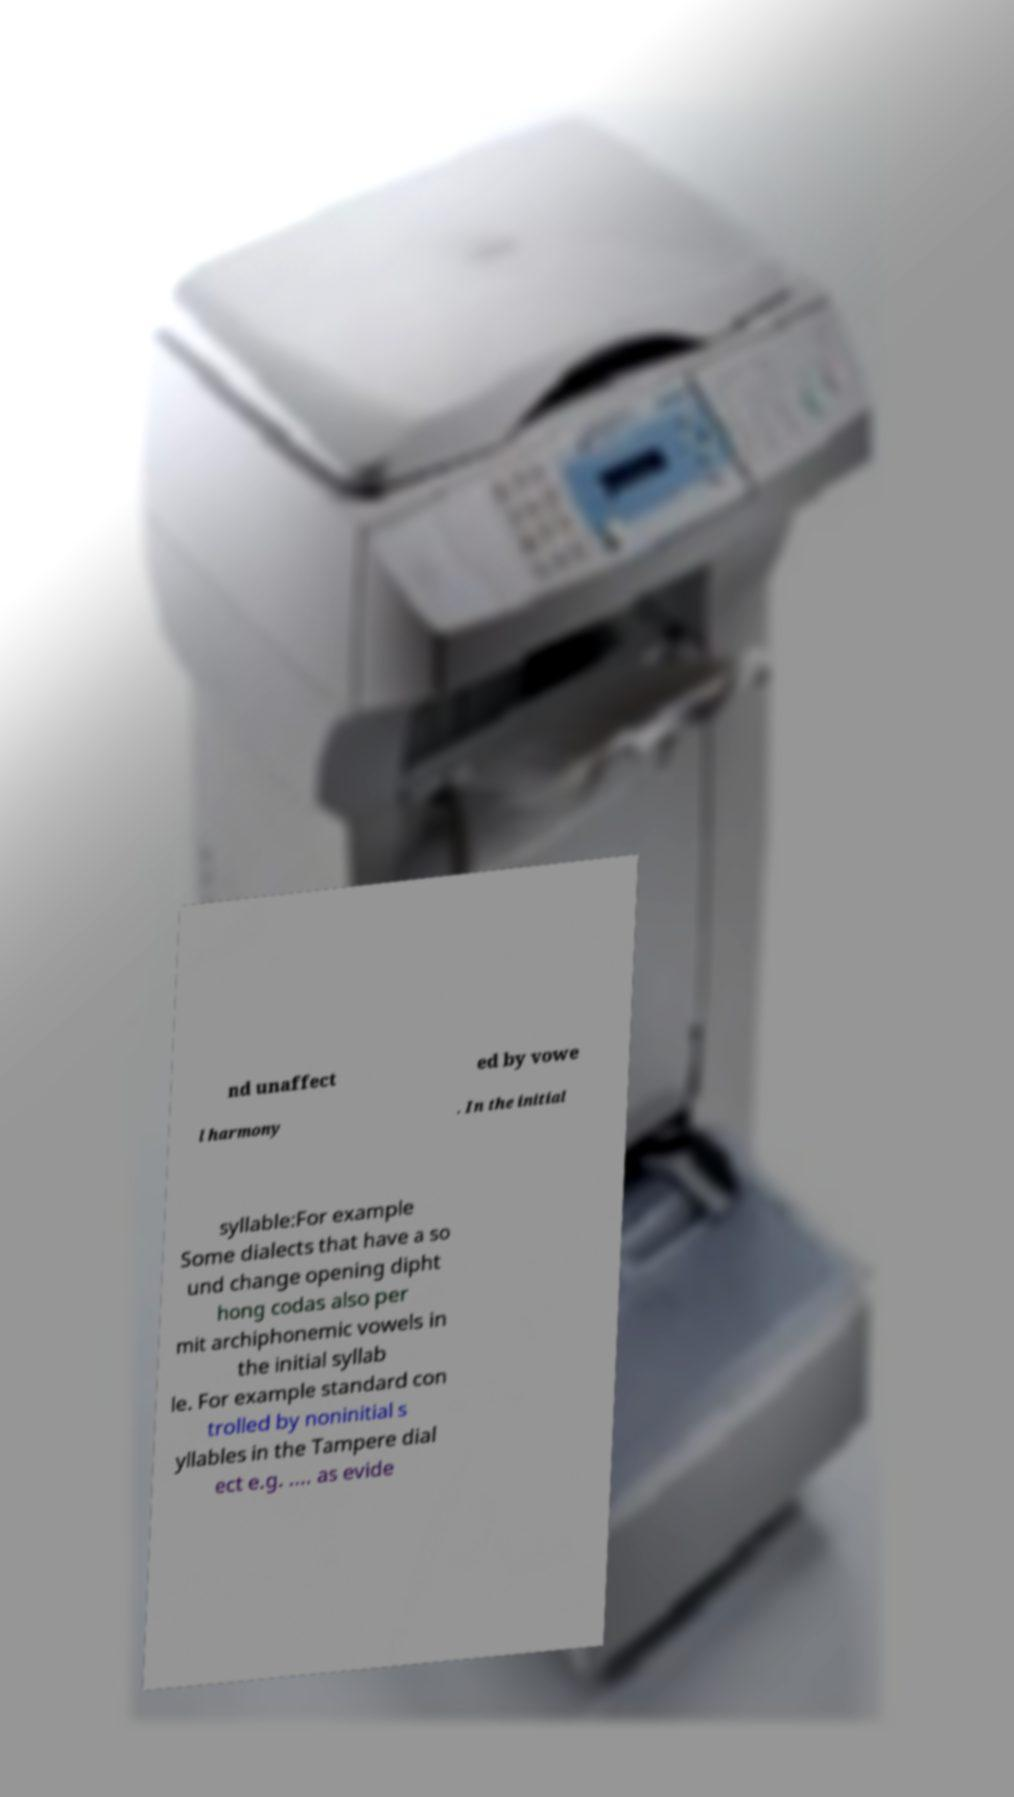Please identify and transcribe the text found in this image. nd unaffect ed by vowe l harmony . In the initial syllable:For example Some dialects that have a so und change opening dipht hong codas also per mit archiphonemic vowels in the initial syllab le. For example standard con trolled by noninitial s yllables in the Tampere dial ect e.g. .... as evide 